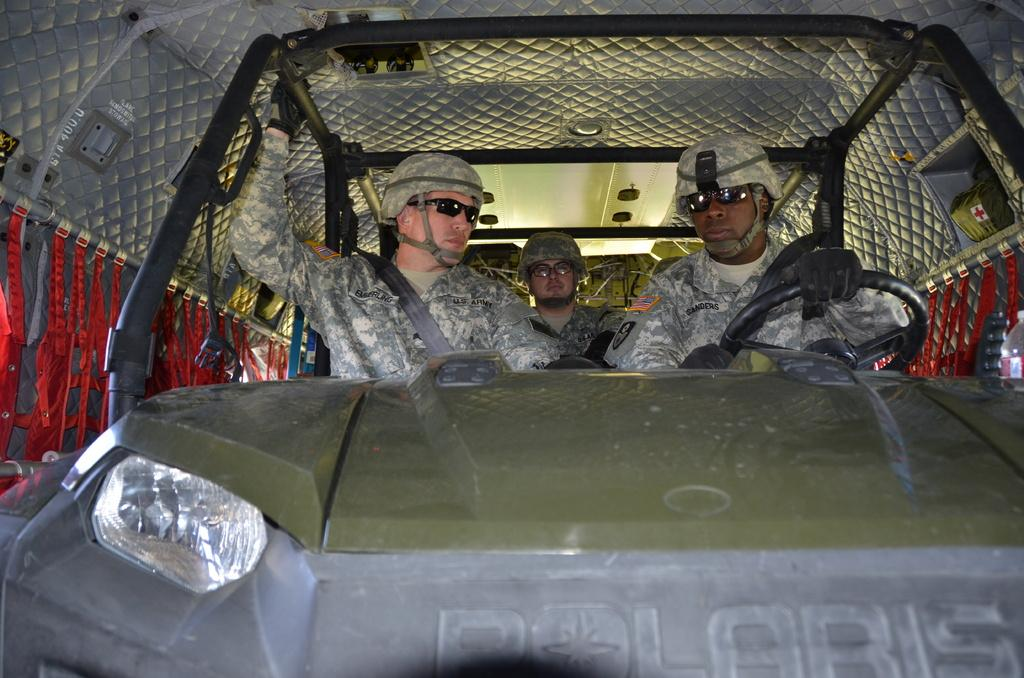How many people are in the image? There are three persons in the image. What are the persons wearing? The persons are wearing army uniforms, helmets, and glasses. What are the persons doing in the image? The three persons are sitting in a car. Can you describe the unique situation of the car in the image? The car is inside another vehicle. What verse from a famous poem can be seen written on the car's windshield? There is no verse from a famous poem visible on the car's windshield in the image. What type of record is being played by the persons in the image? There is no record player or music playing in the image; the persons are wearing army uniforms and sitting in a car. 